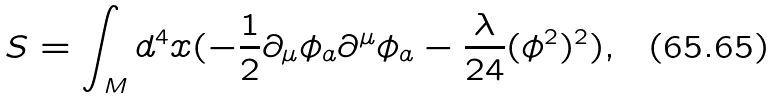Convert formula to latex. <formula><loc_0><loc_0><loc_500><loc_500>S = \int _ { M } d ^ { 4 } x ( - \frac { 1 } { 2 } \partial _ { \mu } \phi _ { a } \partial ^ { \mu } \phi _ { a } - \frac { \lambda } { 2 4 } ( \phi ^ { 2 } ) ^ { 2 } ) ,</formula> 